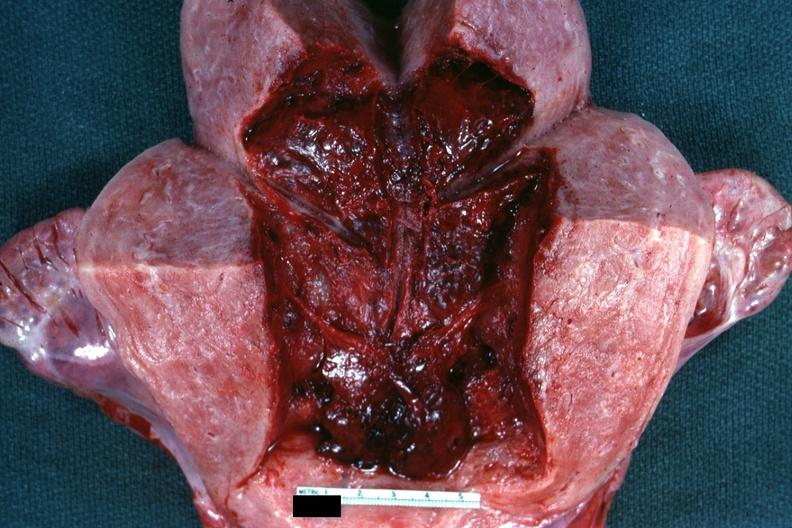where does this belong to?
Answer the question using a single word or phrase. Female reproductive system 